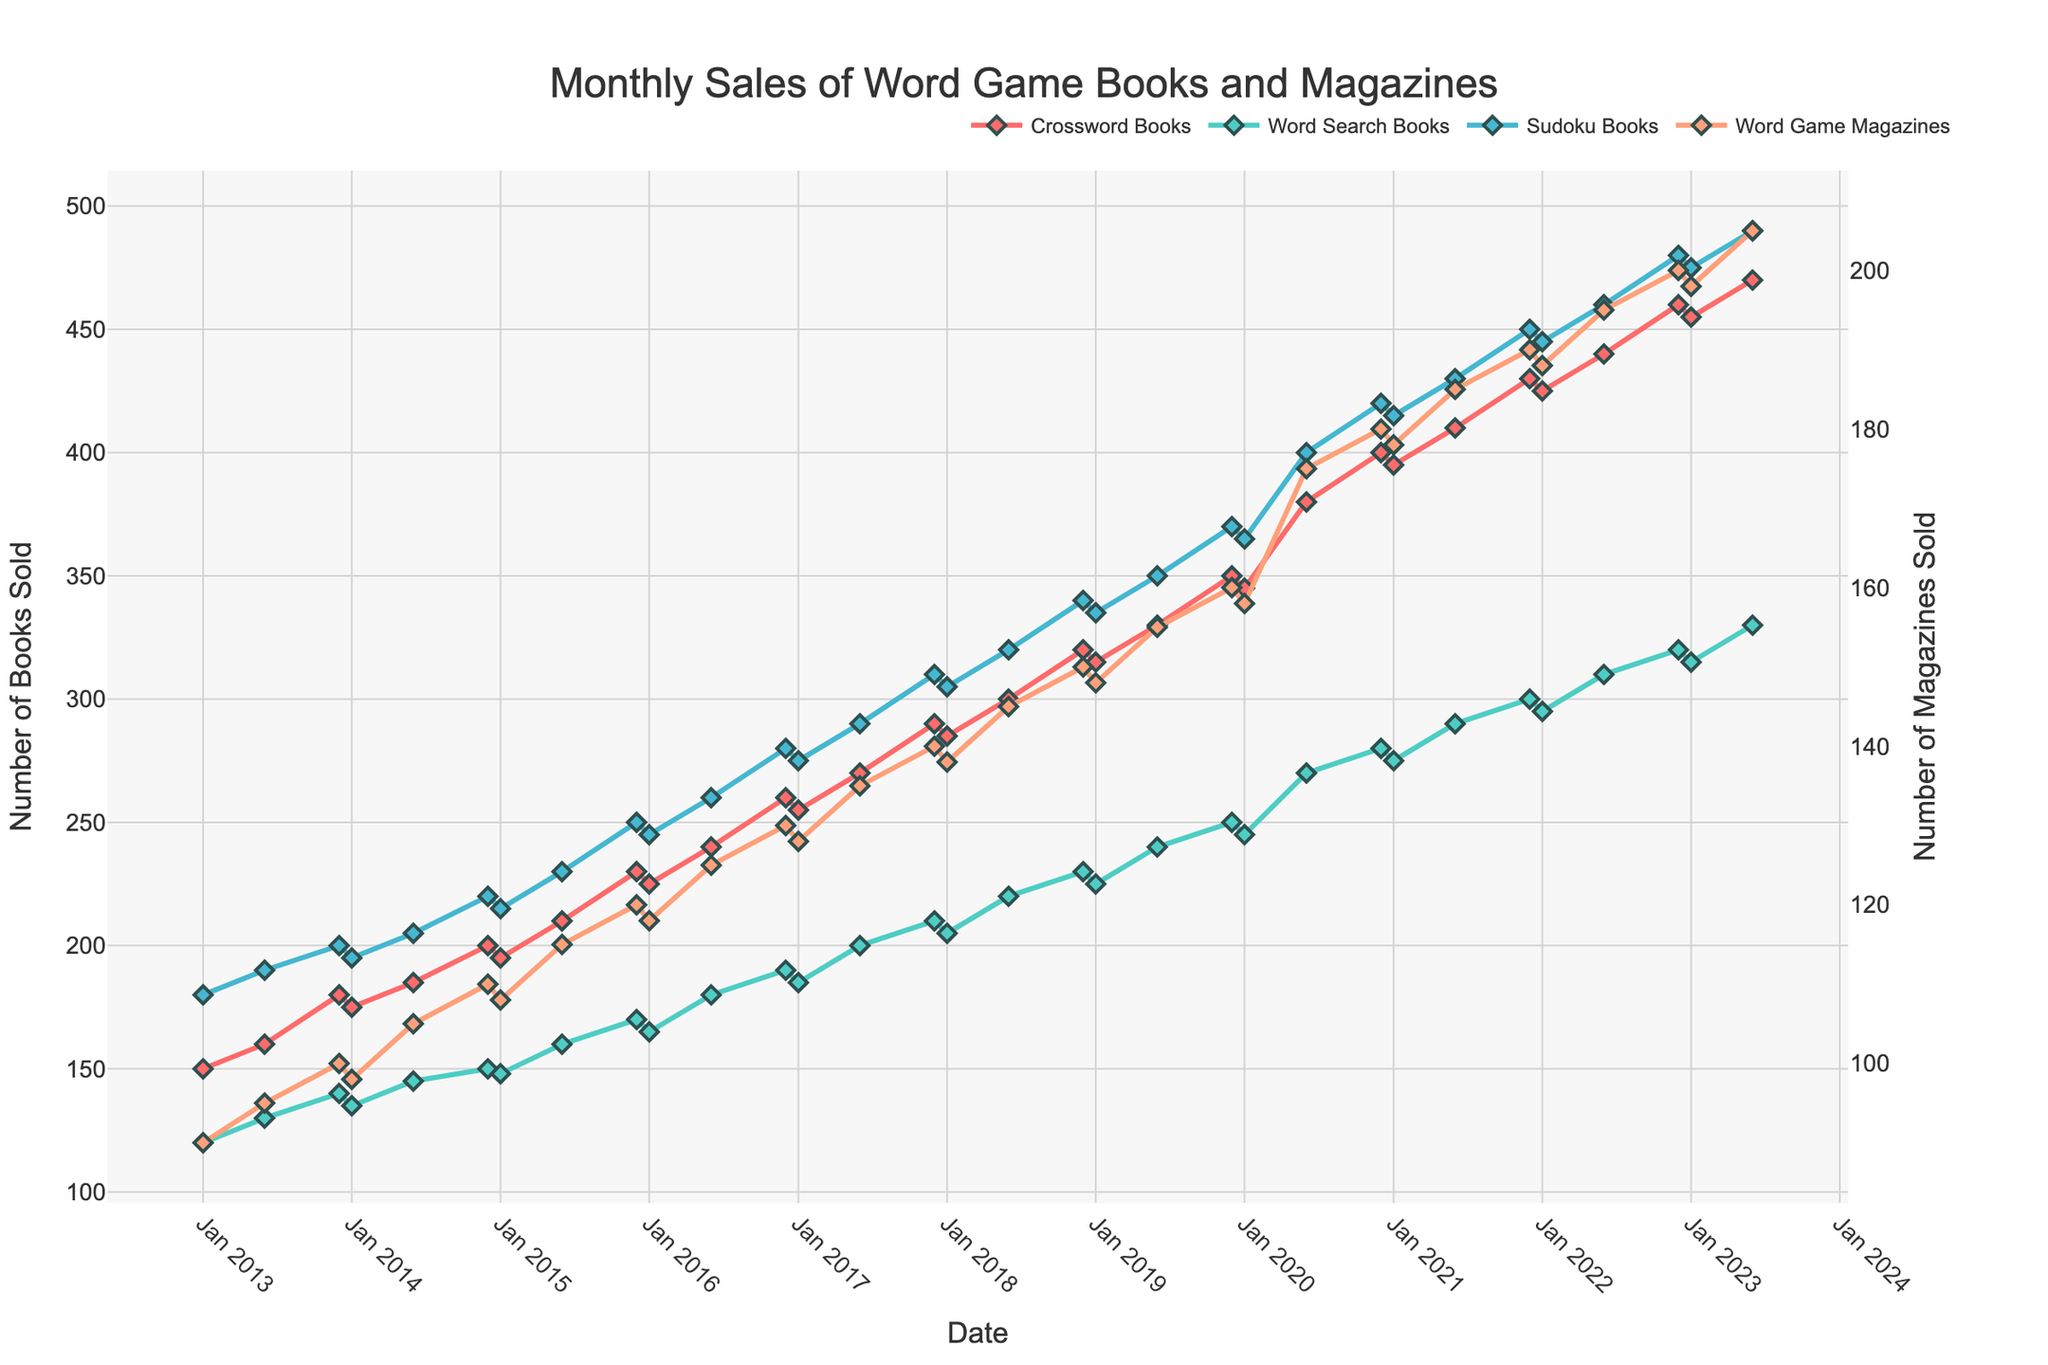What was the highest sales figure for Sudoku Books within the entire decade? We can observe that the highest peak for Sudoku Books is in 2022, December, where it reached 480 in sales.
Answer: 480 Which year showed the most significant increase in sales for Crossword Books from January to December? By comparing the sales figures, we can see that in 2020, sales for Crossword Books went from 345 in January to 400 in December, indicating a significant increase of 55 books.
Answer: 2020 How do the sales figures of Word Game Magazines in June 2020 compare to those in June 2021? In June 2020, the sales were 175, whereas in June 2021, they were 185. This shows an increase.
Answer: Higher in 2021 by 10 What is the average sales figure for Word Search Books across the decade? To calculate the average, sum all the monthly sales figures for Word Search Books and divide by the number of data points. The sum is 7500, and there are 30 data points, so the average is 7500/30 = 250.
Answer: 250 Among the four categories, which one had the highest sales increase from 2017 to 2022 in December? By comparing December sales figures for each category, Crossword Books went from 290 to 460 (170 increase), Word Search Books from 210 to 320 (110 increase), Sudoku Books from 310 to 480 (170 increase), and Word Game Magazines from 140 to 200 (60 increase). The highest increases are observed in Crossword Books and Sudoku Books with both having an increase of 170.
Answer: Crossword Books and Sudoku Books Which category always had higher sales in December compared to the other months in every year? By looking at the sales data, we can see that Sudoku Books consistently had higher sales in December compared to other months through the entire decade.
Answer: Sudoku Books Did any of the categories experience a decline in overall sales throughout the decade? By observing the trends across all categories, we can see that none of the categories experienced an overall decline; all categories show an upward trend.
Answer: None Which category had the smallest range of sales figures throughout the decade? Word Game Magazines range from 90 to 205, so the range is 115. We compare this with other categories: Crossword Books (range 160-470 = 310), Word Search Books (range 120-330 = 210), and Sudoku Books (range 180-490 = 310). Word Game Magazines have the smallest range.
Answer: Word Game Magazines In which month and year did all categories have their maximum sales simultaneously? This did not happen simultaneously. Each category has peak sales in different points in time as observable from the unique highest peaks in each category in the figure.
Answer: Never 